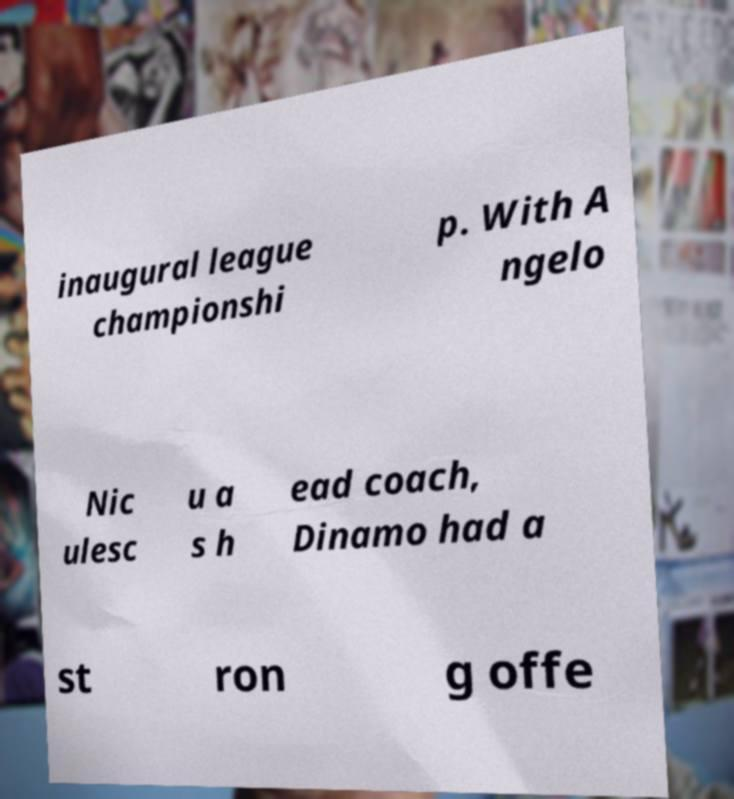There's text embedded in this image that I need extracted. Can you transcribe it verbatim? inaugural league championshi p. With A ngelo Nic ulesc u a s h ead coach, Dinamo had a st ron g offe 